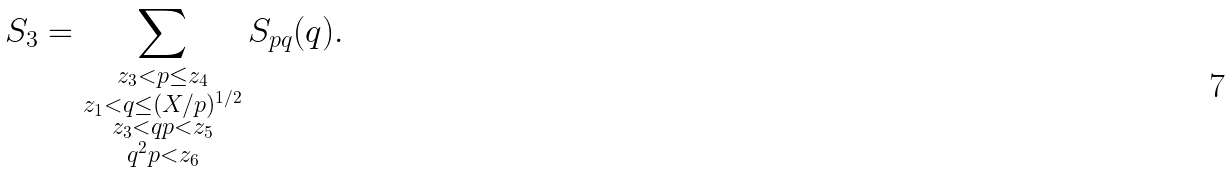<formula> <loc_0><loc_0><loc_500><loc_500>S _ { 3 } = \sum _ { \substack { z _ { 3 } < p \leq z _ { 4 } \\ z _ { 1 } < q \leq ( X / p ) ^ { 1 / 2 } \\ z _ { 3 } < q p < z _ { 5 } \\ q ^ { 2 } p < z _ { 6 } } } S _ { p q } ( q ) .</formula> 